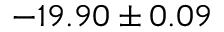Convert formula to latex. <formula><loc_0><loc_0><loc_500><loc_500>- 1 9 . 9 0 \pm 0 . 0 9</formula> 